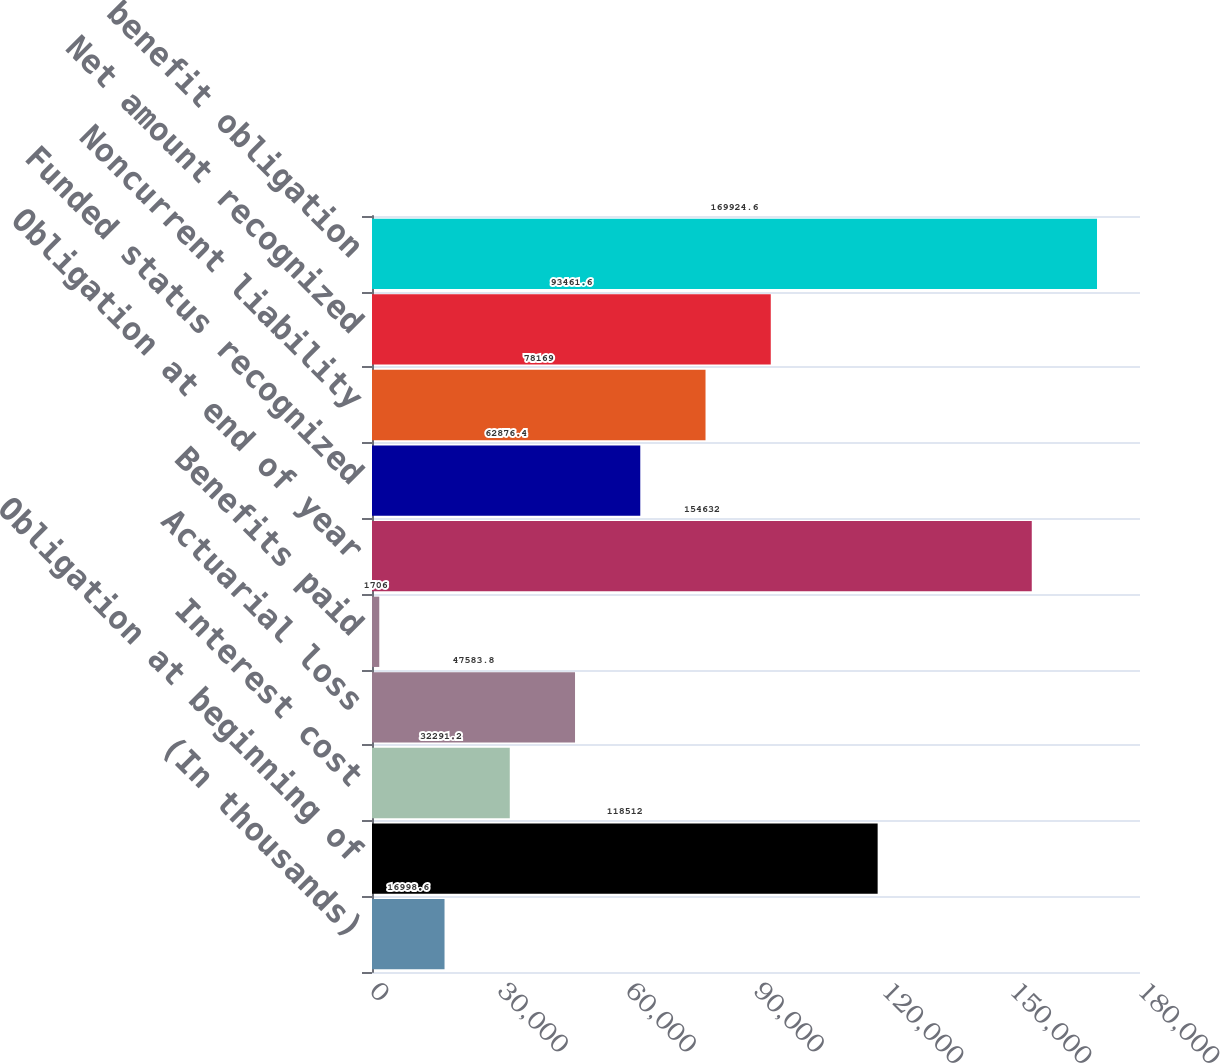Convert chart to OTSL. <chart><loc_0><loc_0><loc_500><loc_500><bar_chart><fcel>(In thousands)<fcel>Obligation at beginning of<fcel>Interest cost<fcel>Actuarial loss<fcel>Benefits paid<fcel>Obligation at end of year<fcel>Funded status recognized<fcel>Noncurrent liability<fcel>Net amount recognized<fcel>Accumulated benefit obligation<nl><fcel>16998.6<fcel>118512<fcel>32291.2<fcel>47583.8<fcel>1706<fcel>154632<fcel>62876.4<fcel>78169<fcel>93461.6<fcel>169925<nl></chart> 